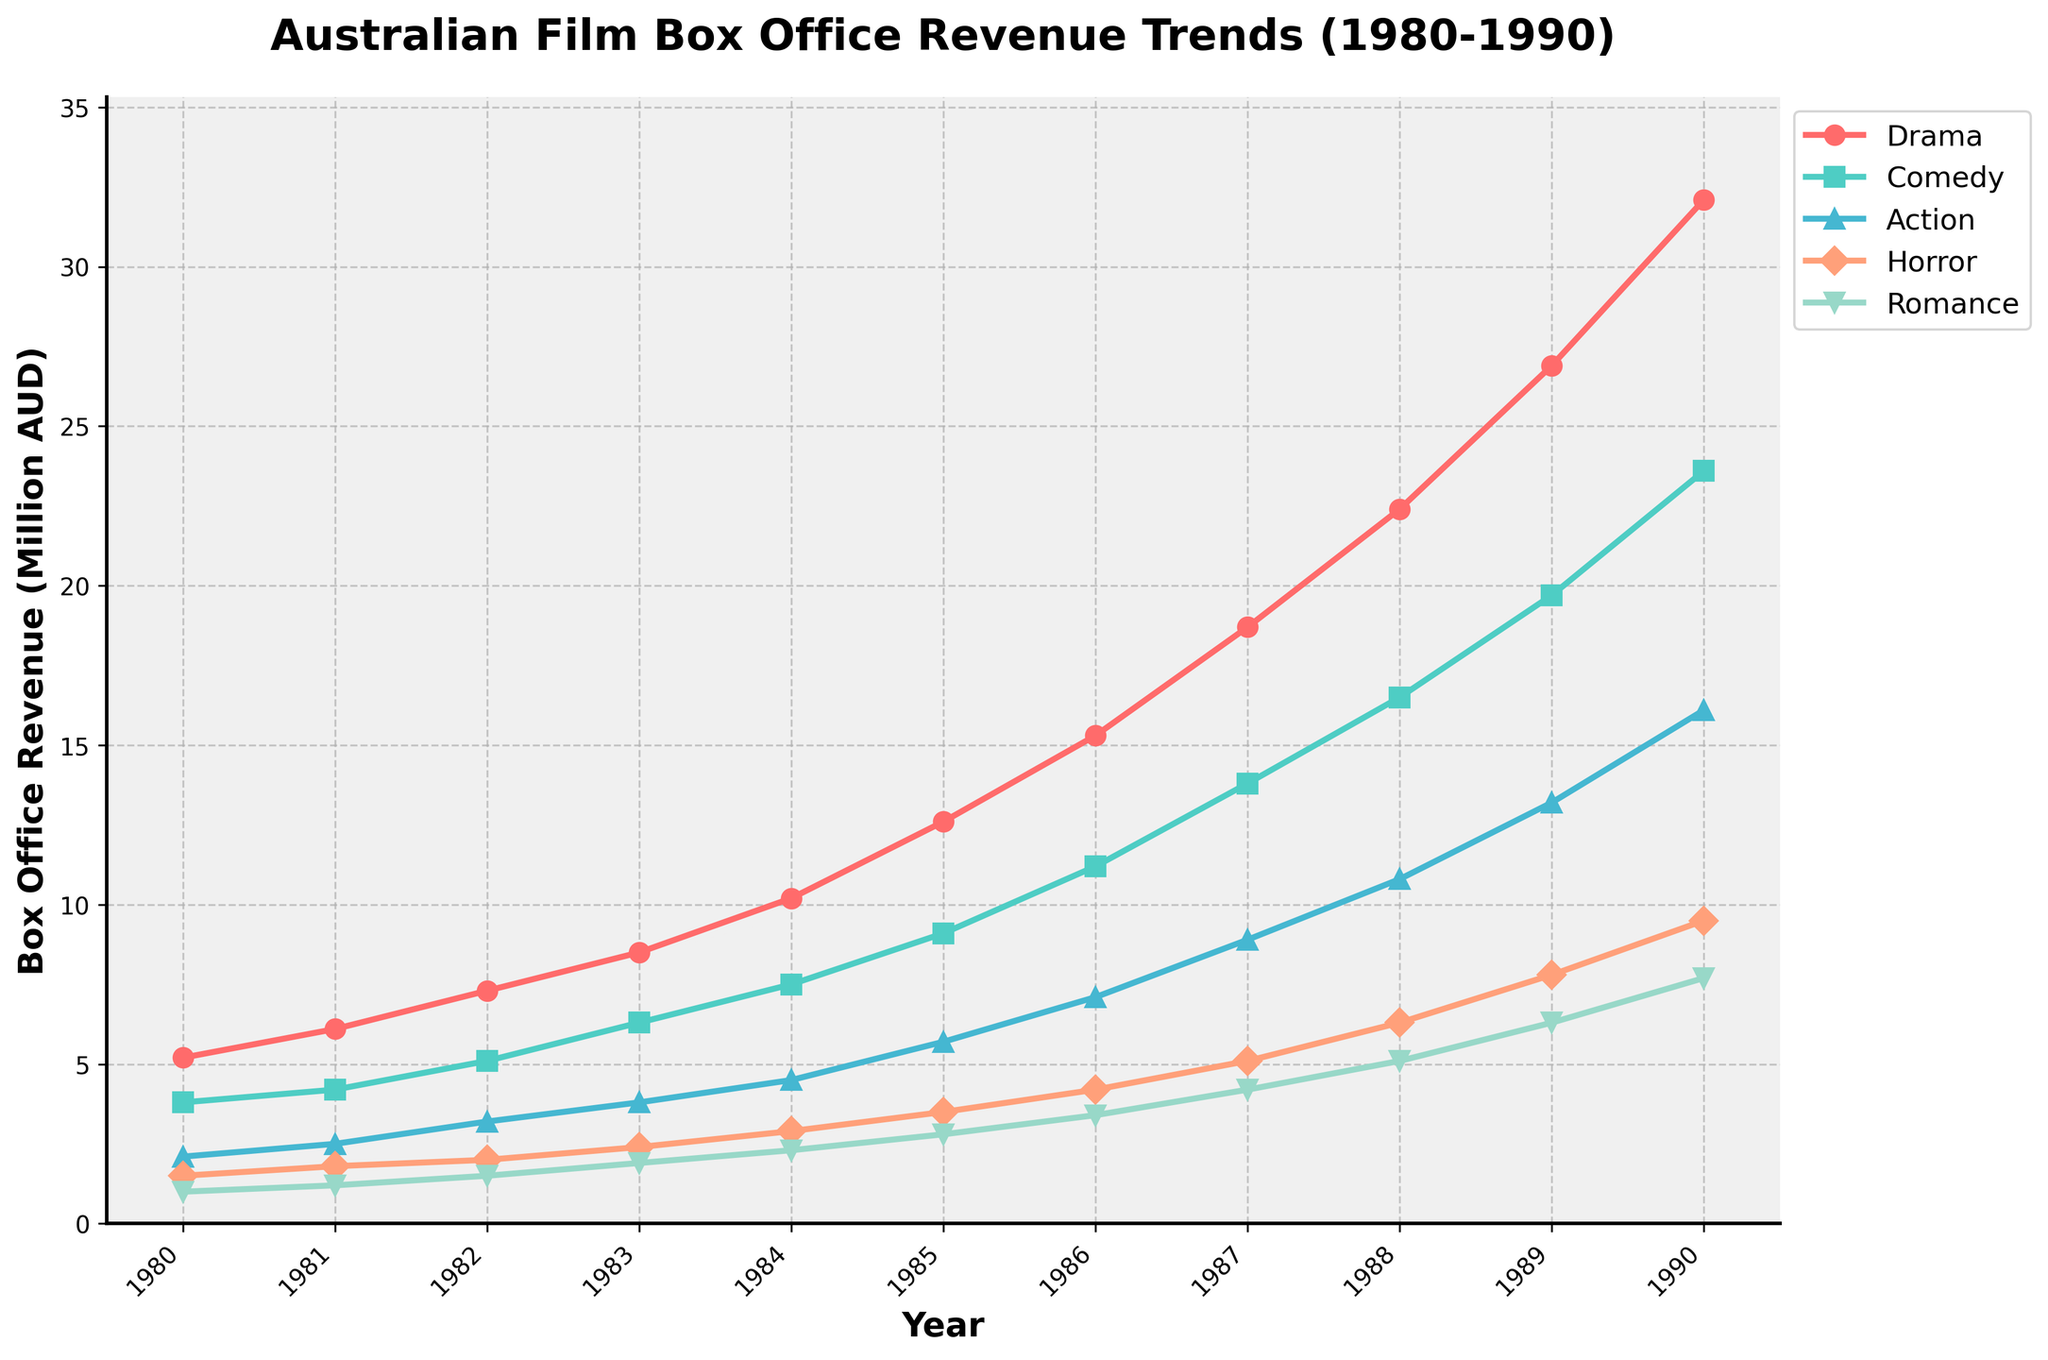What year did Drama films first surpass box office revenue of 10 million AUD? To find when Drama films first surpassed 10 million AUD, look at the Drama line and identify the year where the value exceeds 10. This occurs in 1984 when Drama films hit 10.2 million AUD.
Answer: 1984 Which genre had the highest box office revenue in 1990? Examine the box office revenues for each genre in 1990. Drama is the highest with 32.1 million AUD.
Answer: Drama How does the revenue trend for Comedy compare to Horror from 1980 to 1990? Comparing the Comedy and Horror lines, both increase over time, but Comedy grows more steeply, consistently bringing in higher revenue each year.
Answer: Comedy grows more steeply What is the combined box office revenue for Action and Romance films in 1987? Add the 1987 revenues for Action (8.9 million) and Romance (4.2 million). The combined revenue is 8.9 + 4.2 = 13.1 million AUD.
Answer: 13.1 million AUD By how much did the revenue for Horror films increase from 1980 to 1990? To find the increase, subtract the 1980 value (1.5 million) from the 1990 value (9.5 million). The increase is 9.5 - 1.5 = 8 million AUD.
Answer: 8 million AUD Which genre had the smallest revenue increase between 1980 and 1990? Calculate the revenue increase for each genre. Drama: 32.1 - 5.2 = 26.9 million, Comedy: 23.6 - 3.8 = 19.8 million, Action: 16.1 - 2.1 = 14.0 million, Horror: 9.5 - 1.5 = 8.0 million, Romance: 7.7 - 1.0 = 6.7 million. Romance had the smallest increase of 6.7 million AUD.
Answer: Romance Which year did Comedy overtake Action films in box office revenue? Look for the first year where the Comedy revenue exceeds Action revenue. This occurs in 1984 when Comedy has 7.5 million AUD and Action has 4.5 million AUD.
Answer: 1984 What is the average annual revenue for Horror films over the decade? Sum the annual revenues for Horror from 1980 to 1990 and divide by the number of years. Sum = 1.5 + 1.8 + 2.0 + 2.4 + 2.9 + 3.5 + 4.2 + 5.1 + 6.3 + 7.8 + 9.5 = 47, total years = 11, so average = 47 / 11 ≈ 4.27 million AUD
Answer: 4.27 million AUD What is the overall trend in box office revenue for Romance films from 1980 to 1990? Look at the trend line for Romance films, which steadily increases from 1.0 million AUD in 1980 to 7.7 million AUD in 1990.
Answer: Steadily increasing 